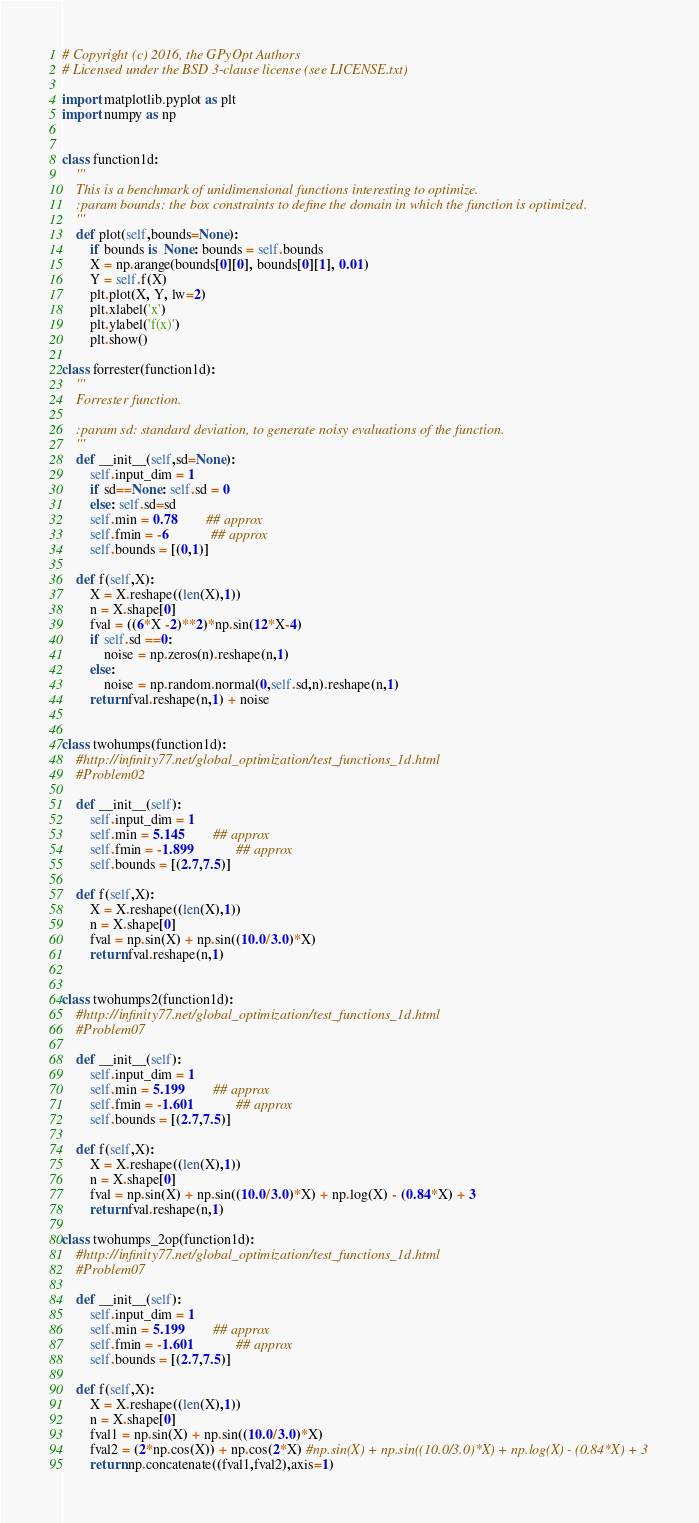<code> <loc_0><loc_0><loc_500><loc_500><_Python_># Copyright (c) 2016, the GPyOpt Authors
# Licensed under the BSD 3-clause license (see LICENSE.txt)

import matplotlib.pyplot as plt
import numpy as np


class function1d:
	'''
	This is a benchmark of unidimensional functions interesting to optimize. 
	:param bounds: the box constraints to define the domain in which the function is optimized.
	'''
	def plot(self,bounds=None):
		if bounds is  None: bounds = self.bounds
		X = np.arange(bounds[0][0], bounds[0][1], 0.01)
		Y = self.f(X)
		plt.plot(X, Y, lw=2)
		plt.xlabel('x')
		plt.ylabel('f(x)')
		plt.show()

class forrester(function1d):
	'''
	Forrester function. 
	
	:param sd: standard deviation, to generate noisy evaluations of the function.
	'''
	def __init__(self,sd=None):
		self.input_dim = 1		
		if sd==None: self.sd = 0
		else: self.sd=sd
		self.min = 0.78 		## approx
		self.fmin = -6 			## approx
		self.bounds = [(0,1)]

	def f(self,X):
		X = X.reshape((len(X),1))
		n = X.shape[0]
		fval = ((6*X -2)**2)*np.sin(12*X-4)
		if self.sd ==0:
			noise = np.zeros(n).reshape(n,1)
		else:
			noise = np.random.normal(0,self.sd,n).reshape(n,1)
		return fval.reshape(n,1) + noise


class twohumps(function1d):
	#http://infinity77.net/global_optimization/test_functions_1d.html
	#Problem02

	def __init__(self):
		self.input_dim = 1		
		self.min = 5.145 		## approx
		self.fmin = -1.899 			## approx
		self.bounds = [(2.7,7.5)]

	def f(self,X):
		X = X.reshape((len(X),1))
		n = X.shape[0]
		fval = np.sin(X) + np.sin((10.0/3.0)*X)
		return fval.reshape(n,1)


class twohumps2(function1d):
	#http://infinity77.net/global_optimization/test_functions_1d.html
	#Problem07

	def __init__(self):
		self.input_dim = 1		
		self.min = 5.199 		## approx
		self.fmin = -1.601			## approx
		self.bounds = [(2.7,7.5)]

	def f(self,X):
		X = X.reshape((len(X),1))
		n = X.shape[0]
		fval = np.sin(X) + np.sin((10.0/3.0)*X) + np.log(X) - (0.84*X) + 3
		return fval.reshape(n,1)

class twohumps_2op(function1d):
	#http://infinity77.net/global_optimization/test_functions_1d.html
	#Problem07

	def __init__(self):
		self.input_dim = 1		
		self.min = 5.199 		## approx
		self.fmin = -1.601			## approx
		self.bounds = [(2.7,7.5)]

	def f(self,X):
		X = X.reshape((len(X),1))
		n = X.shape[0]
		fval1 = np.sin(X) + np.sin((10.0/3.0)*X)
		fval2 = (2*np.cos(X)) + np.cos(2*X) #np.sin(X) + np.sin((10.0/3.0)*X) + np.log(X) - (0.84*X) + 3
		return np.concatenate((fval1,fval2),axis=1) 


</code> 